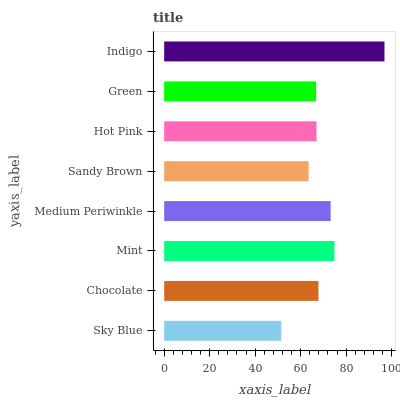Is Sky Blue the minimum?
Answer yes or no. Yes. Is Indigo the maximum?
Answer yes or no. Yes. Is Chocolate the minimum?
Answer yes or no. No. Is Chocolate the maximum?
Answer yes or no. No. Is Chocolate greater than Sky Blue?
Answer yes or no. Yes. Is Sky Blue less than Chocolate?
Answer yes or no. Yes. Is Sky Blue greater than Chocolate?
Answer yes or no. No. Is Chocolate less than Sky Blue?
Answer yes or no. No. Is Chocolate the high median?
Answer yes or no. Yes. Is Hot Pink the low median?
Answer yes or no. Yes. Is Sandy Brown the high median?
Answer yes or no. No. Is Indigo the low median?
Answer yes or no. No. 